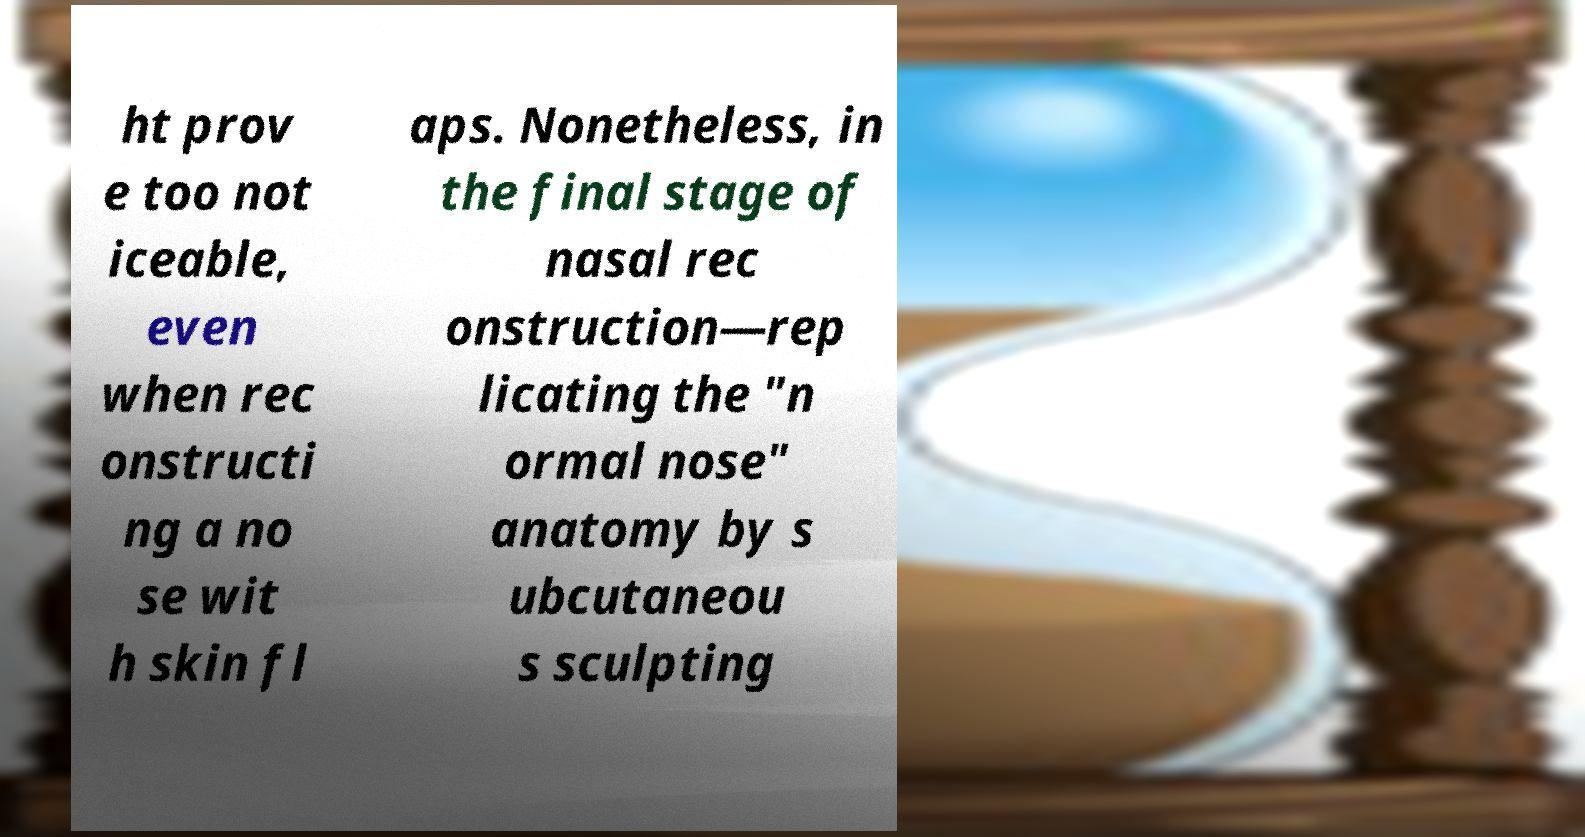I need the written content from this picture converted into text. Can you do that? ht prov e too not iceable, even when rec onstructi ng a no se wit h skin fl aps. Nonetheless, in the final stage of nasal rec onstruction—rep licating the "n ormal nose" anatomy by s ubcutaneou s sculpting 